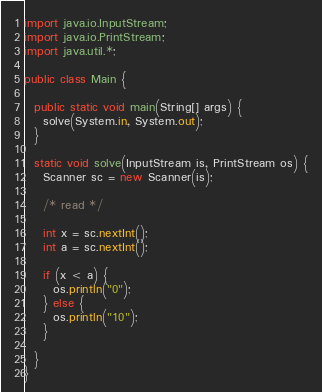Convert code to text. <code><loc_0><loc_0><loc_500><loc_500><_Java_>import java.io.InputStream;
import java.io.PrintStream;
import java.util.*;

public class Main {

  public static void main(String[] args) {
    solve(System.in, System.out);
  }

  static void solve(InputStream is, PrintStream os) {
    Scanner sc = new Scanner(is);

    /* read */

    int x = sc.nextInt();
    int a = sc.nextInt();

    if (x < a) {
      os.println("0");
    } else {
      os.println("10");
    }

  }
}</code> 